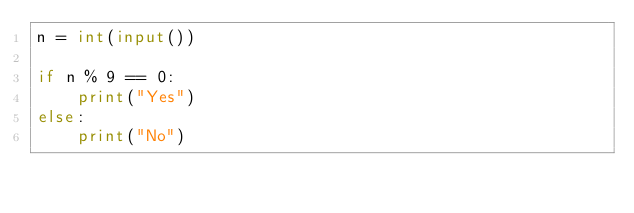Convert code to text. <code><loc_0><loc_0><loc_500><loc_500><_Python_>n = int(input())

if n % 9 == 0:
    print("Yes")
else:
    print("No")</code> 